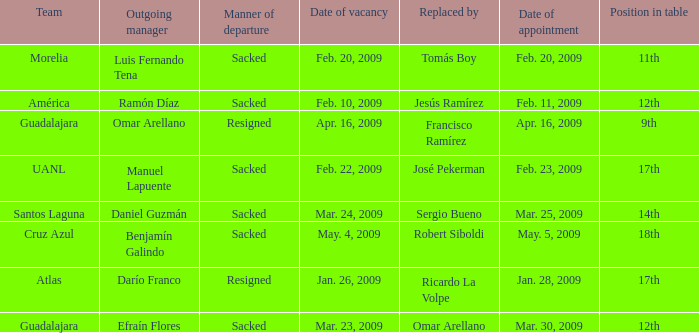What is Position in Table, when Team is "Morelia"? 11th. 